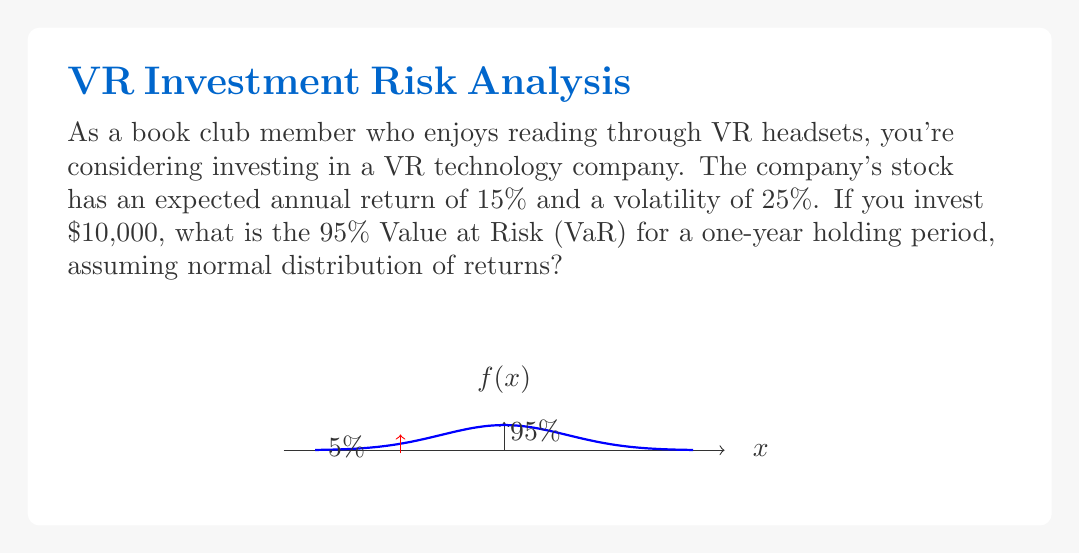Show me your answer to this math problem. To calculate the Value at Risk (VaR) for this investment, we'll follow these steps:

1) The formula for VaR at confidence level $c$ for a normal distribution is:

   $VaR = I \cdot (-\mu + \sigma \cdot z_c)$

   Where:
   $I$ = initial investment
   $\mu$ = expected return
   $\sigma$ = volatility
   $z_c$ = z-score for confidence level $c$

2) We're given:
   $I = \$10,000$
   $\mu = 15\% = 0.15$
   $\sigma = 25\% = 0.25$
   Confidence level = 95%, so $z_c = 1.645$ (standard normal table)

3) Plugging these values into the formula:

   $VaR = 10000 \cdot (-0.15 + 0.25 \cdot 1.645)$

4) Calculating:
   $VaR = 10000 \cdot (-0.15 + 0.41125)$
   $VaR = 10000 \cdot 0.26125$
   $VaR = 2612.5$

5) The VaR represents the potential loss, so we round up to be conservative.

Therefore, the 95% VaR for this investment over a one-year period is $2,613.
Answer: $2,613 